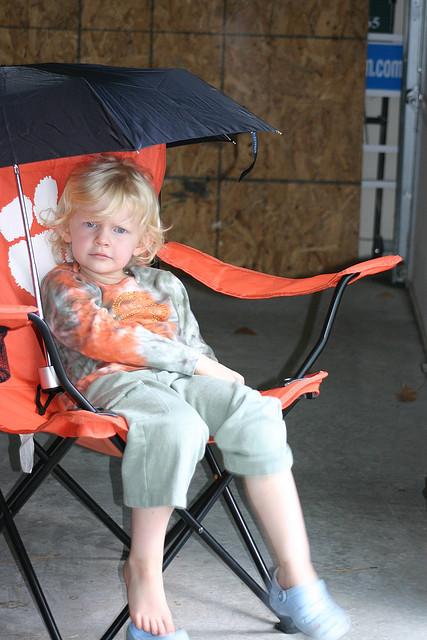What object is in the chair with the child?
Concise answer only. Umbrella. Is the child holding the umbrella?
Be succinct. No. How many shoes is the kid wearing?
Concise answer only. 1. What pattern is on the child's shirt?
Give a very brief answer. Tie dye. 